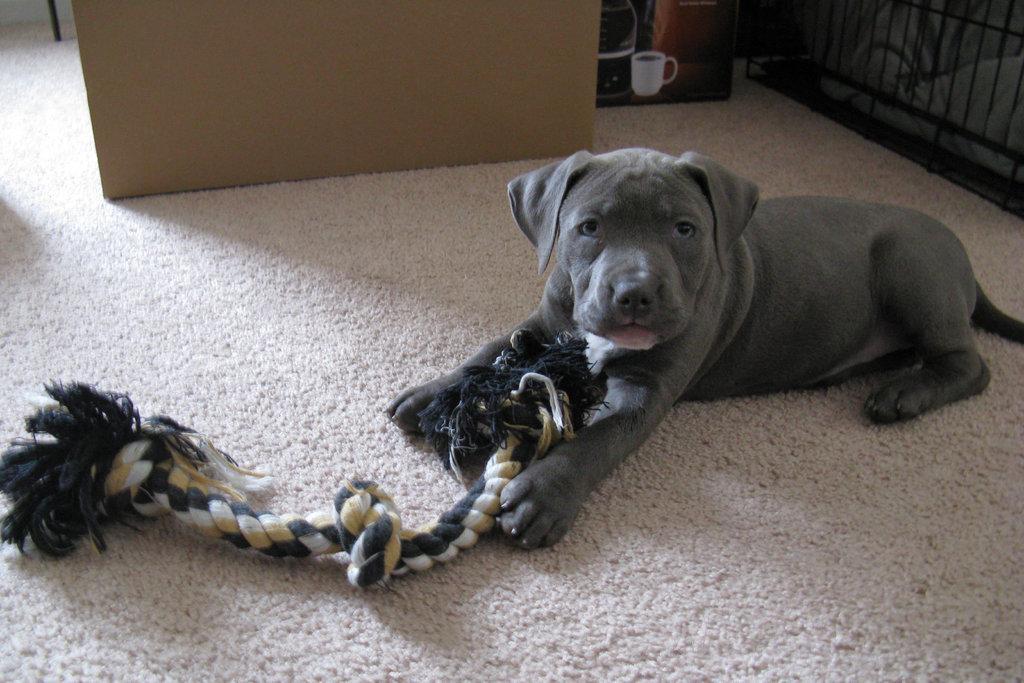Can you describe this image briefly? There is a dog and a rope on the carpet. Here we can see a cup on the box. 